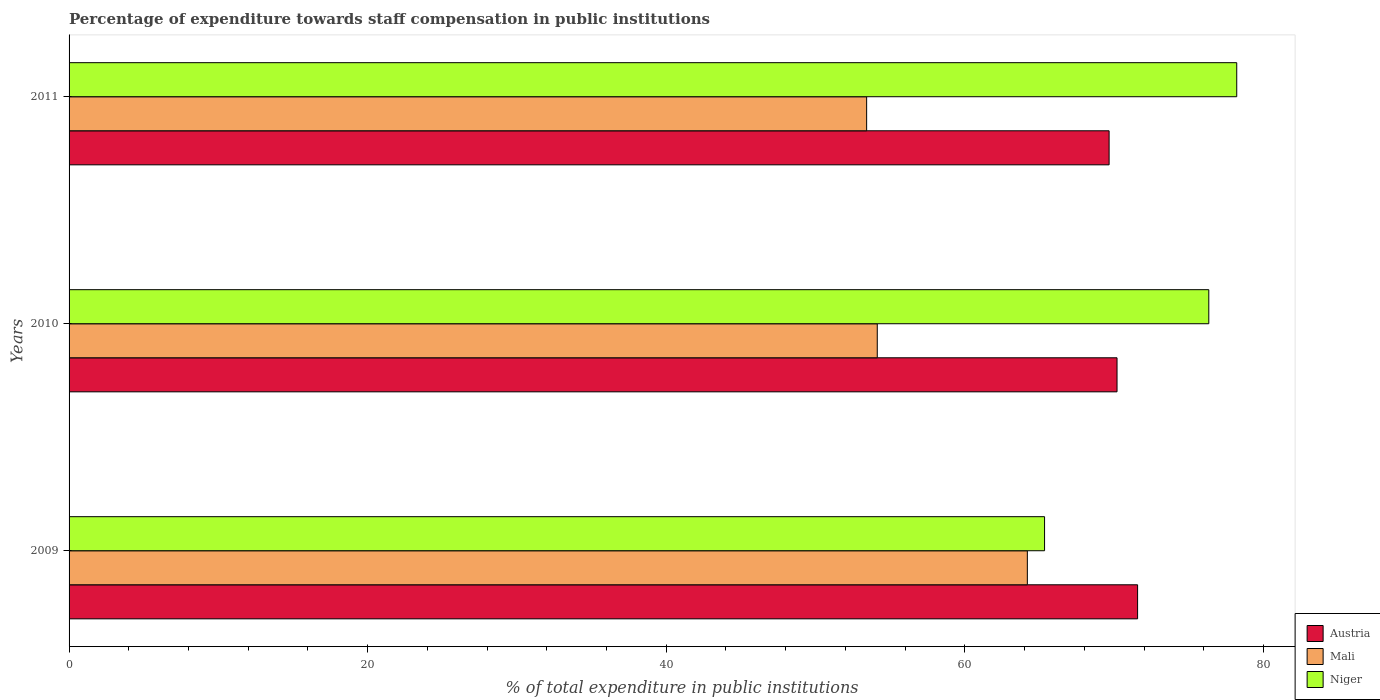How many different coloured bars are there?
Your response must be concise. 3. Are the number of bars on each tick of the Y-axis equal?
Your response must be concise. Yes. How many bars are there on the 1st tick from the top?
Your response must be concise. 3. How many bars are there on the 3rd tick from the bottom?
Make the answer very short. 3. What is the percentage of expenditure towards staff compensation in Mali in 2011?
Give a very brief answer. 53.42. Across all years, what is the maximum percentage of expenditure towards staff compensation in Mali?
Give a very brief answer. 64.19. Across all years, what is the minimum percentage of expenditure towards staff compensation in Austria?
Your answer should be very brief. 69.66. In which year was the percentage of expenditure towards staff compensation in Niger maximum?
Your answer should be compact. 2011. In which year was the percentage of expenditure towards staff compensation in Mali minimum?
Provide a short and direct response. 2011. What is the total percentage of expenditure towards staff compensation in Austria in the graph?
Your answer should be very brief. 211.42. What is the difference between the percentage of expenditure towards staff compensation in Niger in 2009 and that in 2010?
Your answer should be very brief. -11. What is the difference between the percentage of expenditure towards staff compensation in Mali in 2009 and the percentage of expenditure towards staff compensation in Niger in 2011?
Give a very brief answer. -14.02. What is the average percentage of expenditure towards staff compensation in Austria per year?
Provide a short and direct response. 70.47. In the year 2009, what is the difference between the percentage of expenditure towards staff compensation in Niger and percentage of expenditure towards staff compensation in Mali?
Ensure brevity in your answer.  1.15. What is the ratio of the percentage of expenditure towards staff compensation in Niger in 2009 to that in 2011?
Make the answer very short. 0.84. Is the percentage of expenditure towards staff compensation in Austria in 2010 less than that in 2011?
Make the answer very short. No. Is the difference between the percentage of expenditure towards staff compensation in Niger in 2009 and 2010 greater than the difference between the percentage of expenditure towards staff compensation in Mali in 2009 and 2010?
Keep it short and to the point. No. What is the difference between the highest and the second highest percentage of expenditure towards staff compensation in Austria?
Make the answer very short. 1.38. What is the difference between the highest and the lowest percentage of expenditure towards staff compensation in Austria?
Your response must be concise. 1.91. In how many years, is the percentage of expenditure towards staff compensation in Mali greater than the average percentage of expenditure towards staff compensation in Mali taken over all years?
Offer a terse response. 1. What does the 3rd bar from the top in 2010 represents?
Your answer should be compact. Austria. What does the 3rd bar from the bottom in 2011 represents?
Your answer should be compact. Niger. Is it the case that in every year, the sum of the percentage of expenditure towards staff compensation in Niger and percentage of expenditure towards staff compensation in Austria is greater than the percentage of expenditure towards staff compensation in Mali?
Make the answer very short. Yes. How many bars are there?
Provide a succinct answer. 9. How many years are there in the graph?
Keep it short and to the point. 3. What is the difference between two consecutive major ticks on the X-axis?
Offer a terse response. 20. Does the graph contain grids?
Provide a succinct answer. No. What is the title of the graph?
Make the answer very short. Percentage of expenditure towards staff compensation in public institutions. What is the label or title of the X-axis?
Offer a terse response. % of total expenditure in public institutions. What is the label or title of the Y-axis?
Make the answer very short. Years. What is the % of total expenditure in public institutions in Austria in 2009?
Make the answer very short. 71.57. What is the % of total expenditure in public institutions in Mali in 2009?
Ensure brevity in your answer.  64.19. What is the % of total expenditure in public institutions in Niger in 2009?
Make the answer very short. 65.34. What is the % of total expenditure in public institutions in Austria in 2010?
Your answer should be compact. 70.19. What is the % of total expenditure in public institutions of Mali in 2010?
Make the answer very short. 54.13. What is the % of total expenditure in public institutions of Niger in 2010?
Provide a succinct answer. 76.34. What is the % of total expenditure in public institutions in Austria in 2011?
Provide a short and direct response. 69.66. What is the % of total expenditure in public institutions in Mali in 2011?
Offer a terse response. 53.42. What is the % of total expenditure in public institutions in Niger in 2011?
Your answer should be compact. 78.21. Across all years, what is the maximum % of total expenditure in public institutions in Austria?
Provide a short and direct response. 71.57. Across all years, what is the maximum % of total expenditure in public institutions in Mali?
Give a very brief answer. 64.19. Across all years, what is the maximum % of total expenditure in public institutions in Niger?
Make the answer very short. 78.21. Across all years, what is the minimum % of total expenditure in public institutions of Austria?
Provide a short and direct response. 69.66. Across all years, what is the minimum % of total expenditure in public institutions of Mali?
Keep it short and to the point. 53.42. Across all years, what is the minimum % of total expenditure in public institutions of Niger?
Provide a succinct answer. 65.34. What is the total % of total expenditure in public institutions in Austria in the graph?
Offer a terse response. 211.42. What is the total % of total expenditure in public institutions of Mali in the graph?
Give a very brief answer. 171.74. What is the total % of total expenditure in public institutions of Niger in the graph?
Keep it short and to the point. 219.89. What is the difference between the % of total expenditure in public institutions in Austria in 2009 and that in 2010?
Ensure brevity in your answer.  1.38. What is the difference between the % of total expenditure in public institutions of Mali in 2009 and that in 2010?
Keep it short and to the point. 10.05. What is the difference between the % of total expenditure in public institutions in Niger in 2009 and that in 2010?
Offer a very short reply. -11. What is the difference between the % of total expenditure in public institutions in Austria in 2009 and that in 2011?
Provide a short and direct response. 1.91. What is the difference between the % of total expenditure in public institutions in Mali in 2009 and that in 2011?
Your answer should be very brief. 10.76. What is the difference between the % of total expenditure in public institutions in Niger in 2009 and that in 2011?
Provide a short and direct response. -12.87. What is the difference between the % of total expenditure in public institutions of Austria in 2010 and that in 2011?
Make the answer very short. 0.53. What is the difference between the % of total expenditure in public institutions in Mali in 2010 and that in 2011?
Ensure brevity in your answer.  0.71. What is the difference between the % of total expenditure in public institutions in Niger in 2010 and that in 2011?
Give a very brief answer. -1.87. What is the difference between the % of total expenditure in public institutions of Austria in 2009 and the % of total expenditure in public institutions of Mali in 2010?
Keep it short and to the point. 17.44. What is the difference between the % of total expenditure in public institutions of Austria in 2009 and the % of total expenditure in public institutions of Niger in 2010?
Provide a short and direct response. -4.77. What is the difference between the % of total expenditure in public institutions of Mali in 2009 and the % of total expenditure in public institutions of Niger in 2010?
Your answer should be very brief. -12.15. What is the difference between the % of total expenditure in public institutions of Austria in 2009 and the % of total expenditure in public institutions of Mali in 2011?
Ensure brevity in your answer.  18.15. What is the difference between the % of total expenditure in public institutions in Austria in 2009 and the % of total expenditure in public institutions in Niger in 2011?
Provide a short and direct response. -6.64. What is the difference between the % of total expenditure in public institutions in Mali in 2009 and the % of total expenditure in public institutions in Niger in 2011?
Your answer should be very brief. -14.02. What is the difference between the % of total expenditure in public institutions in Austria in 2010 and the % of total expenditure in public institutions in Mali in 2011?
Make the answer very short. 16.77. What is the difference between the % of total expenditure in public institutions in Austria in 2010 and the % of total expenditure in public institutions in Niger in 2011?
Your response must be concise. -8.02. What is the difference between the % of total expenditure in public institutions of Mali in 2010 and the % of total expenditure in public institutions of Niger in 2011?
Make the answer very short. -24.08. What is the average % of total expenditure in public institutions in Austria per year?
Keep it short and to the point. 70.47. What is the average % of total expenditure in public institutions in Mali per year?
Ensure brevity in your answer.  57.25. What is the average % of total expenditure in public institutions of Niger per year?
Provide a short and direct response. 73.3. In the year 2009, what is the difference between the % of total expenditure in public institutions of Austria and % of total expenditure in public institutions of Mali?
Provide a short and direct response. 7.38. In the year 2009, what is the difference between the % of total expenditure in public institutions of Austria and % of total expenditure in public institutions of Niger?
Ensure brevity in your answer.  6.23. In the year 2009, what is the difference between the % of total expenditure in public institutions of Mali and % of total expenditure in public institutions of Niger?
Provide a succinct answer. -1.15. In the year 2010, what is the difference between the % of total expenditure in public institutions of Austria and % of total expenditure in public institutions of Mali?
Keep it short and to the point. 16.06. In the year 2010, what is the difference between the % of total expenditure in public institutions of Austria and % of total expenditure in public institutions of Niger?
Your answer should be very brief. -6.15. In the year 2010, what is the difference between the % of total expenditure in public institutions of Mali and % of total expenditure in public institutions of Niger?
Your answer should be compact. -22.21. In the year 2011, what is the difference between the % of total expenditure in public institutions of Austria and % of total expenditure in public institutions of Mali?
Make the answer very short. 16.24. In the year 2011, what is the difference between the % of total expenditure in public institutions of Austria and % of total expenditure in public institutions of Niger?
Provide a succinct answer. -8.55. In the year 2011, what is the difference between the % of total expenditure in public institutions of Mali and % of total expenditure in public institutions of Niger?
Your response must be concise. -24.79. What is the ratio of the % of total expenditure in public institutions of Austria in 2009 to that in 2010?
Make the answer very short. 1.02. What is the ratio of the % of total expenditure in public institutions in Mali in 2009 to that in 2010?
Provide a short and direct response. 1.19. What is the ratio of the % of total expenditure in public institutions of Niger in 2009 to that in 2010?
Offer a terse response. 0.86. What is the ratio of the % of total expenditure in public institutions of Austria in 2009 to that in 2011?
Provide a succinct answer. 1.03. What is the ratio of the % of total expenditure in public institutions of Mali in 2009 to that in 2011?
Give a very brief answer. 1.2. What is the ratio of the % of total expenditure in public institutions of Niger in 2009 to that in 2011?
Keep it short and to the point. 0.84. What is the ratio of the % of total expenditure in public institutions of Austria in 2010 to that in 2011?
Offer a very short reply. 1.01. What is the ratio of the % of total expenditure in public institutions of Mali in 2010 to that in 2011?
Ensure brevity in your answer.  1.01. What is the ratio of the % of total expenditure in public institutions of Niger in 2010 to that in 2011?
Make the answer very short. 0.98. What is the difference between the highest and the second highest % of total expenditure in public institutions of Austria?
Offer a very short reply. 1.38. What is the difference between the highest and the second highest % of total expenditure in public institutions of Mali?
Your answer should be compact. 10.05. What is the difference between the highest and the second highest % of total expenditure in public institutions in Niger?
Offer a terse response. 1.87. What is the difference between the highest and the lowest % of total expenditure in public institutions of Austria?
Keep it short and to the point. 1.91. What is the difference between the highest and the lowest % of total expenditure in public institutions in Mali?
Give a very brief answer. 10.76. What is the difference between the highest and the lowest % of total expenditure in public institutions of Niger?
Make the answer very short. 12.87. 